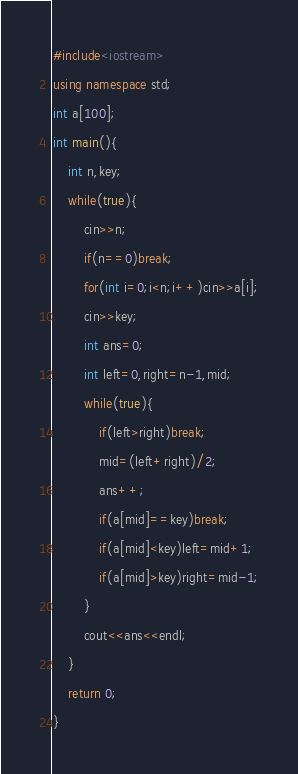<code> <loc_0><loc_0><loc_500><loc_500><_C++_>#include<iostream>
using namespace std;
int a[100];
int main(){
	int n,key;
	while(true){
		cin>>n;
		if(n==0)break;
		for(int i=0;i<n;i++)cin>>a[i];
		cin>>key;
		int ans=0;
		int left=0,right=n-1,mid;
		while(true){
			if(left>right)break;
			mid=(left+right)/2;
			ans++;
			if(a[mid]==key)break;
			if(a[mid]<key)left=mid+1;
			if(a[mid]>key)right=mid-1;
		}
		cout<<ans<<endl;
	}
	return 0;
}</code> 